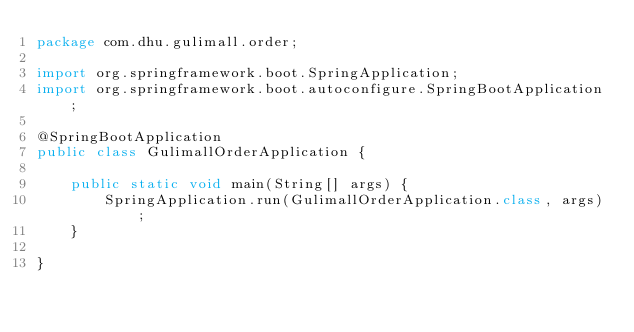Convert code to text. <code><loc_0><loc_0><loc_500><loc_500><_Java_>package com.dhu.gulimall.order;

import org.springframework.boot.SpringApplication;
import org.springframework.boot.autoconfigure.SpringBootApplication;

@SpringBootApplication
public class GulimallOrderApplication {

    public static void main(String[] args) {
        SpringApplication.run(GulimallOrderApplication.class, args);
    }

}
</code> 